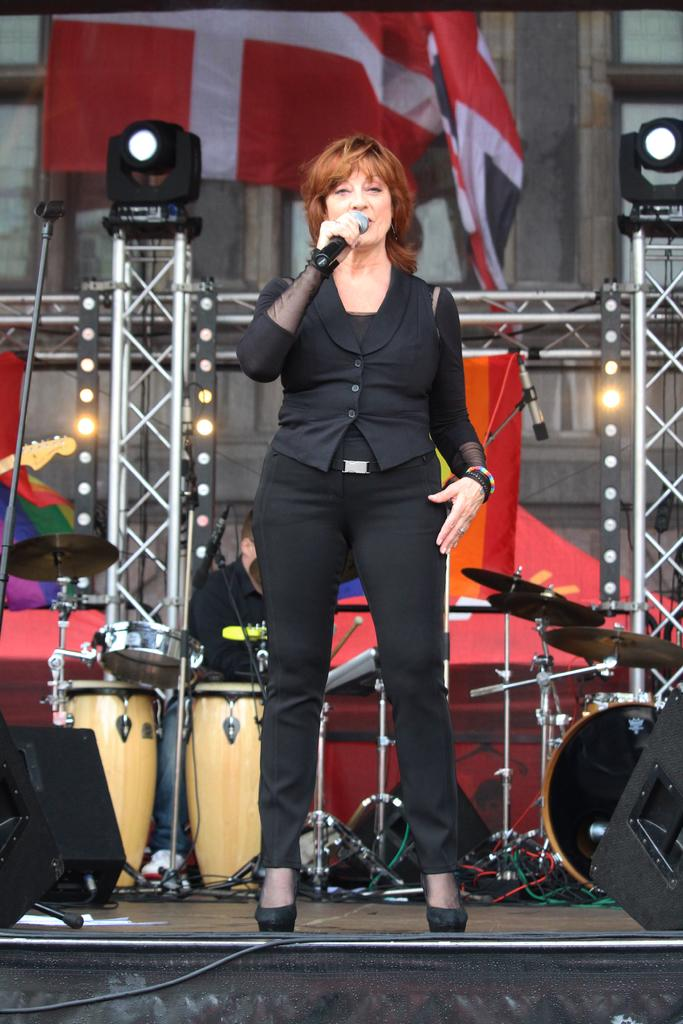How many people are present in the image? There are two people in the image. What is the woman doing on the stage? The woman is standing on the stage and holding a microphone. What can be seen in the background of the image? There is a flag and a building in the background of the image. What is used to illuminate the stage? There are lights on the stage. What type of letter is the woman reading on stage? There is no letter present in the image; the woman is holding a microphone. Can you see any toothpaste on the stage? There is no toothpaste visible in the image. 